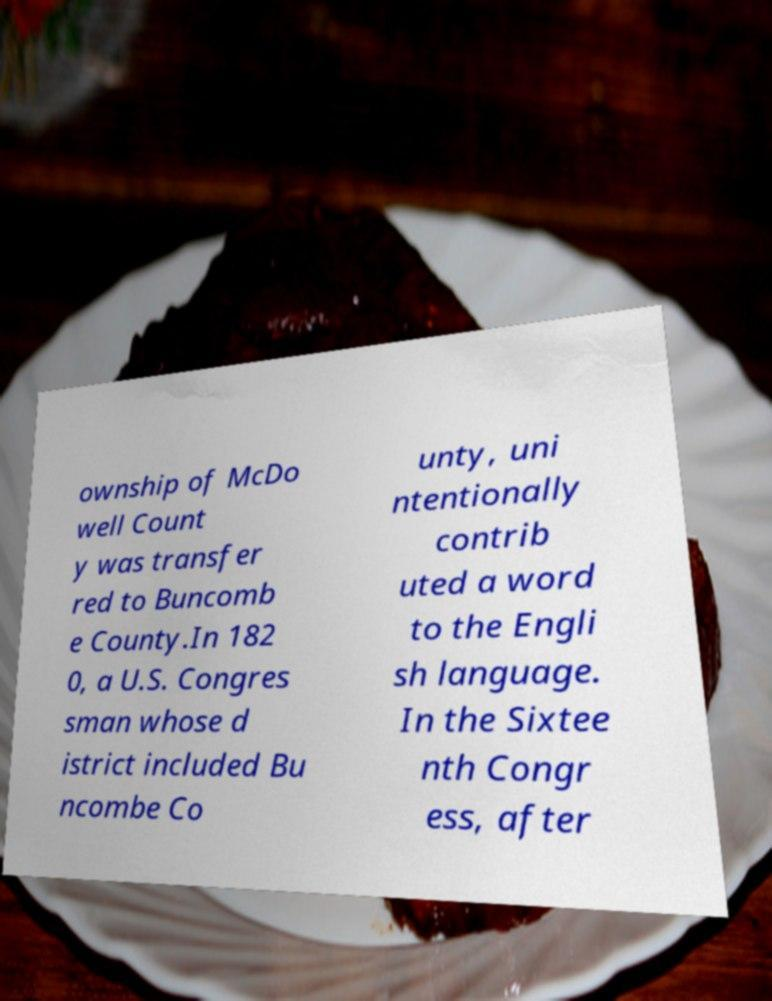Could you assist in decoding the text presented in this image and type it out clearly? ownship of McDo well Count y was transfer red to Buncomb e County.In 182 0, a U.S. Congres sman whose d istrict included Bu ncombe Co unty, uni ntentionally contrib uted a word to the Engli sh language. In the Sixtee nth Congr ess, after 